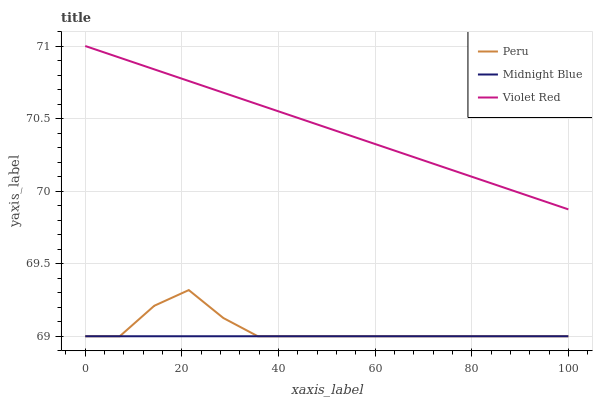Does Midnight Blue have the minimum area under the curve?
Answer yes or no. Yes. Does Violet Red have the maximum area under the curve?
Answer yes or no. Yes. Does Peru have the minimum area under the curve?
Answer yes or no. No. Does Peru have the maximum area under the curve?
Answer yes or no. No. Is Midnight Blue the smoothest?
Answer yes or no. Yes. Is Peru the roughest?
Answer yes or no. Yes. Is Peru the smoothest?
Answer yes or no. No. Is Midnight Blue the roughest?
Answer yes or no. No. Does Violet Red have the highest value?
Answer yes or no. Yes. Does Peru have the highest value?
Answer yes or no. No. Is Peru less than Violet Red?
Answer yes or no. Yes. Is Violet Red greater than Midnight Blue?
Answer yes or no. Yes. Does Peru intersect Midnight Blue?
Answer yes or no. Yes. Is Peru less than Midnight Blue?
Answer yes or no. No. Is Peru greater than Midnight Blue?
Answer yes or no. No. Does Peru intersect Violet Red?
Answer yes or no. No. 